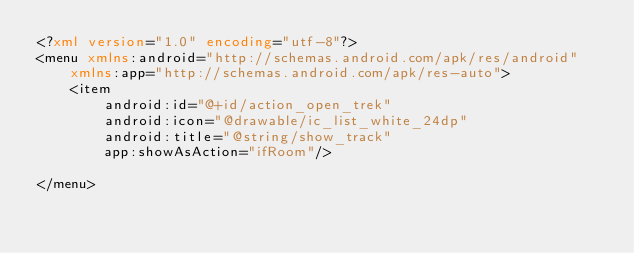<code> <loc_0><loc_0><loc_500><loc_500><_XML_><?xml version="1.0" encoding="utf-8"?>
<menu xmlns:android="http://schemas.android.com/apk/res/android"
    xmlns:app="http://schemas.android.com/apk/res-auto">
    <item
        android:id="@+id/action_open_trek"
        android:icon="@drawable/ic_list_white_24dp"
        android:title="@string/show_track"
        app:showAsAction="ifRoom"/>

</menu></code> 